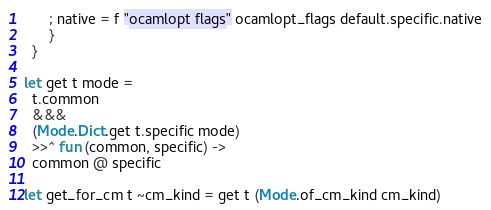<code> <loc_0><loc_0><loc_500><loc_500><_OCaml_>      ; native = f "ocamlopt flags" ocamlopt_flags default.specific.native
      }
  }

let get t mode =
  t.common
  &&&
  (Mode.Dict.get t.specific mode)
  >>^ fun (common, specific) ->
  common @ specific

let get_for_cm t ~cm_kind = get t (Mode.of_cm_kind cm_kind)
</code> 